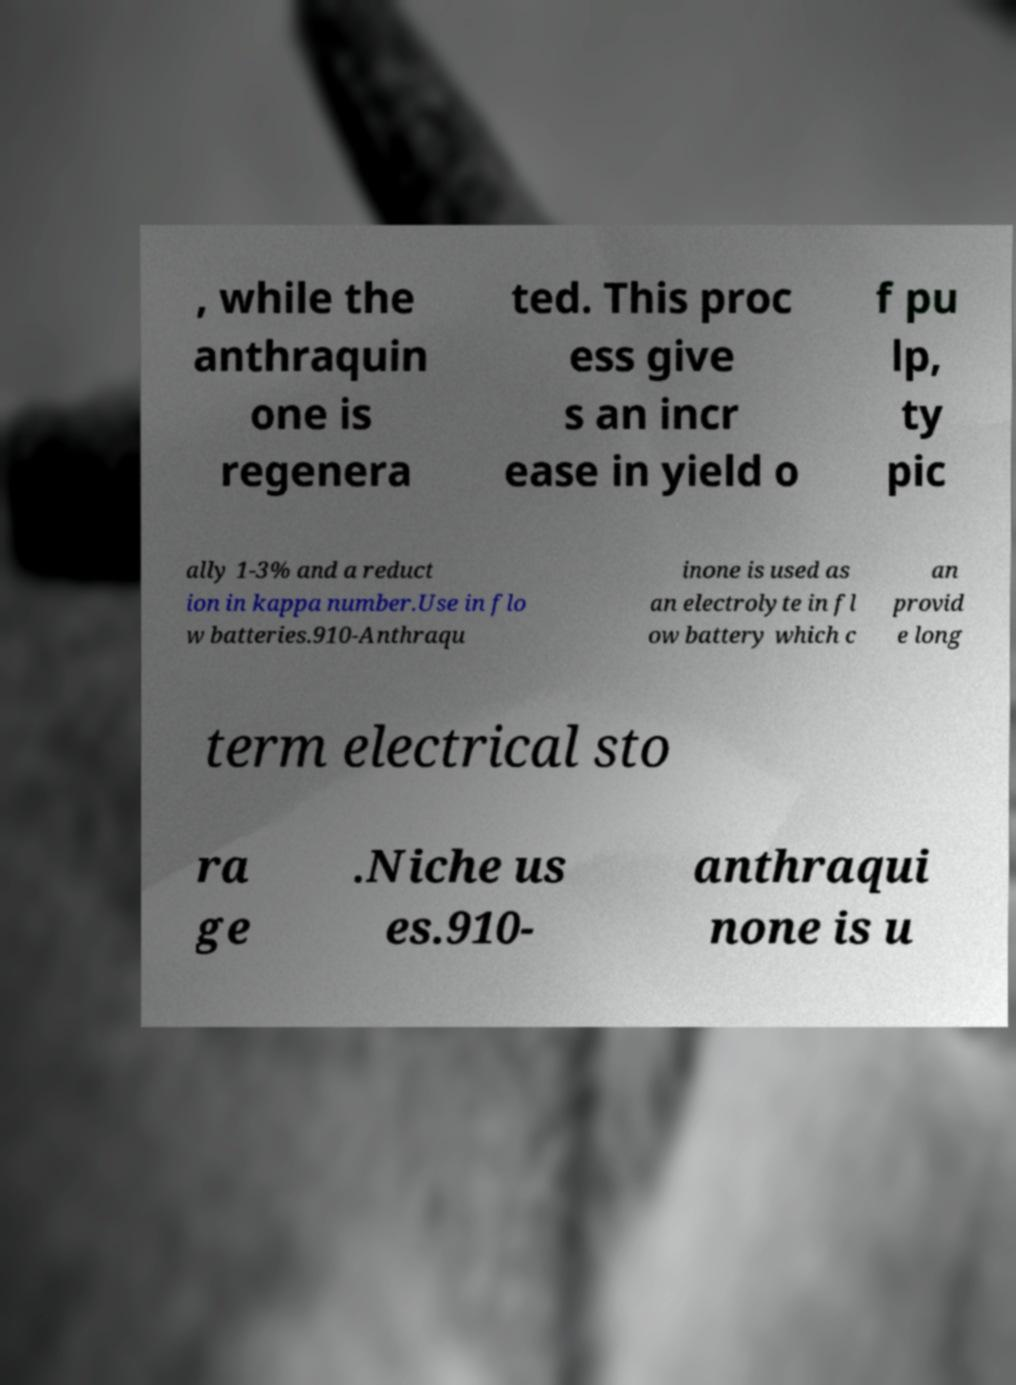There's text embedded in this image that I need extracted. Can you transcribe it verbatim? , while the anthraquin one is regenera ted. This proc ess give s an incr ease in yield o f pu lp, ty pic ally 1-3% and a reduct ion in kappa number.Use in flo w batteries.910-Anthraqu inone is used as an electrolyte in fl ow battery which c an provid e long term electrical sto ra ge .Niche us es.910- anthraqui none is u 